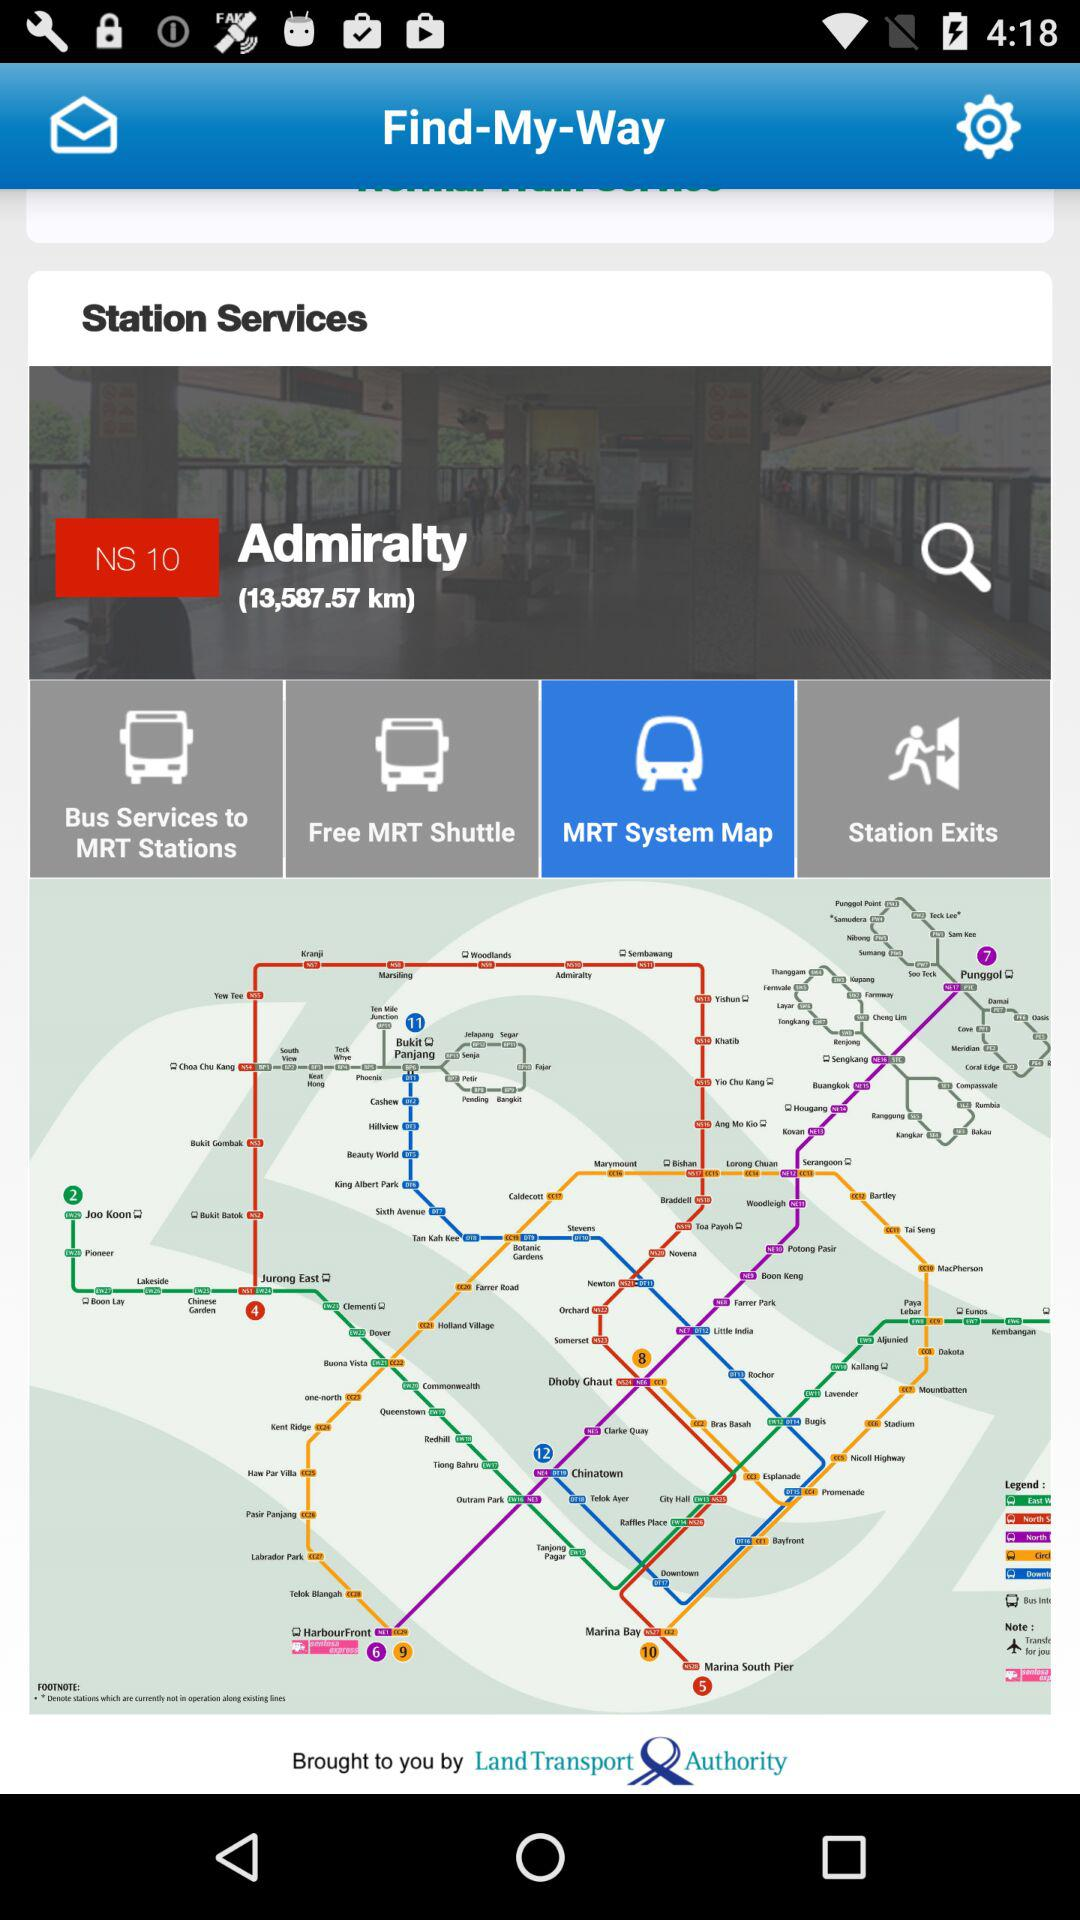Which is the nearest station?
When the provided information is insufficient, respond with <no answer>. <no answer> 